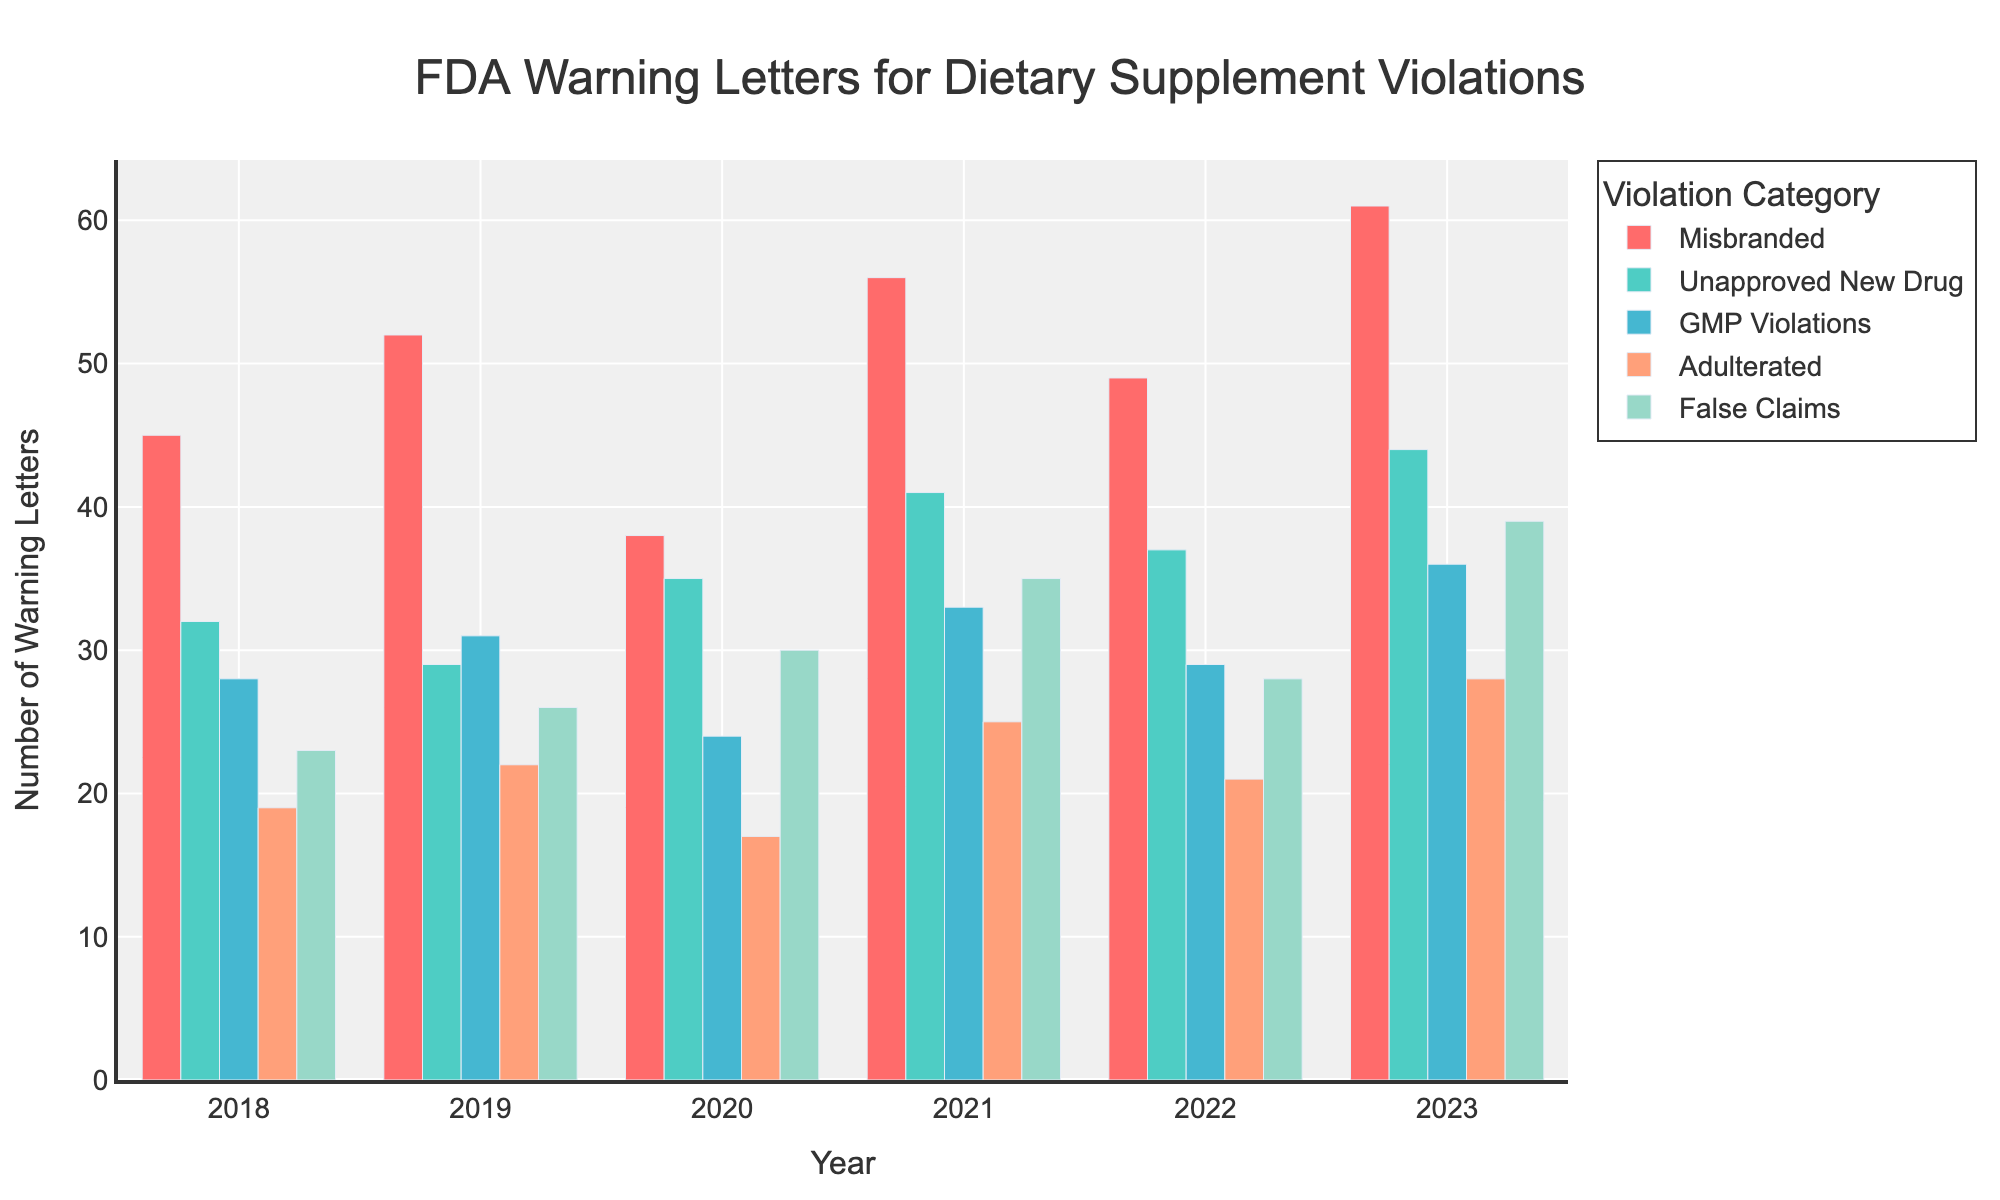What is the total number of FDA warning letters issued in 2023 for all violation categories combined? To find the total number of warning letters issued in 2023, sum the counts for each violation category: Misbranded (61), Unapproved New Drug (44), GMP Violations (36), Adulterated (28), and False Claims (39). The total is 61 + 44 + 36 + 28 + 39 = 208.
Answer: 208 Which year had the highest number of warning letters for Misbranded violations? Look at the bar heights for Misbranded violations across all years. The tallest bar for Misbranded is in 2023, with 61 warning letters.
Answer: 2023 How does the number of warning letters for GMP Violations in 2021 compare to the number in 2022? Compare the bar heights for GMP Violations in 2021 (33 warning letters) and 2022 (29 warning letters). There were more warning letters in 2021.
Answer: More in 2021 In which category and year is the lowest number of warning letters issued? Identify the smallest bars across all categories and years. The lowest number is for Adulterated violations in 2020, with 17 warning letters.
Answer: Adulterated, 2020 What is the average number of warning letters issued for False Claims violations over the years provided? To find the average, sum the number of warning letters for False Claims for each year (23, 26, 30, 35, 28, 39) and divide by the number of years. The sum is 181, and the average is 181/6 = 30.17, approximately.
Answer: 30.17 Which violation category generally shows an increasing trend from 2018 to 2023? Compare the bar heights for each violation category year by year. The category with a general increasing trend is Misbranded, starting at 45 in 2018 and steadily rising to 61 in 2023.
Answer: Misbranded How many more warning letters were issued for Adulterated violations in 2023 compared to 2020? Subtract the number of warning letters for Adulterated violations in 2020 (17) from those in 2023 (28). The difference is 28 - 17 = 11.
Answer: 11 Which two categories had the same number of warning letters issued in 2022? Identify categories with matching bar heights in 2022. Unapproved New Drug and Adulterated both have 21 warning letters in 2022.
Answer: Unapproved New Drug and Adulterated In which year did Unapproved New Drug violations see the highest increase compared to the previous year? Analyze the bar heights year by year for Unapproved New Drug violations. The highest increase is between 2020 (35 warning letters) and 2021 (41 warning letters), an increase of 6.
Answer: 2021 Is the number of warning letters for False Claims in 2020 greater than the total number for Adulterated violations across 2018-2020? First, sum the number of Adulterated violations for 2018-2020: 19+22+17 = 58. Compare this to False Claims in 2020, which is 30. 30 is not greater than 58.
Answer: No 